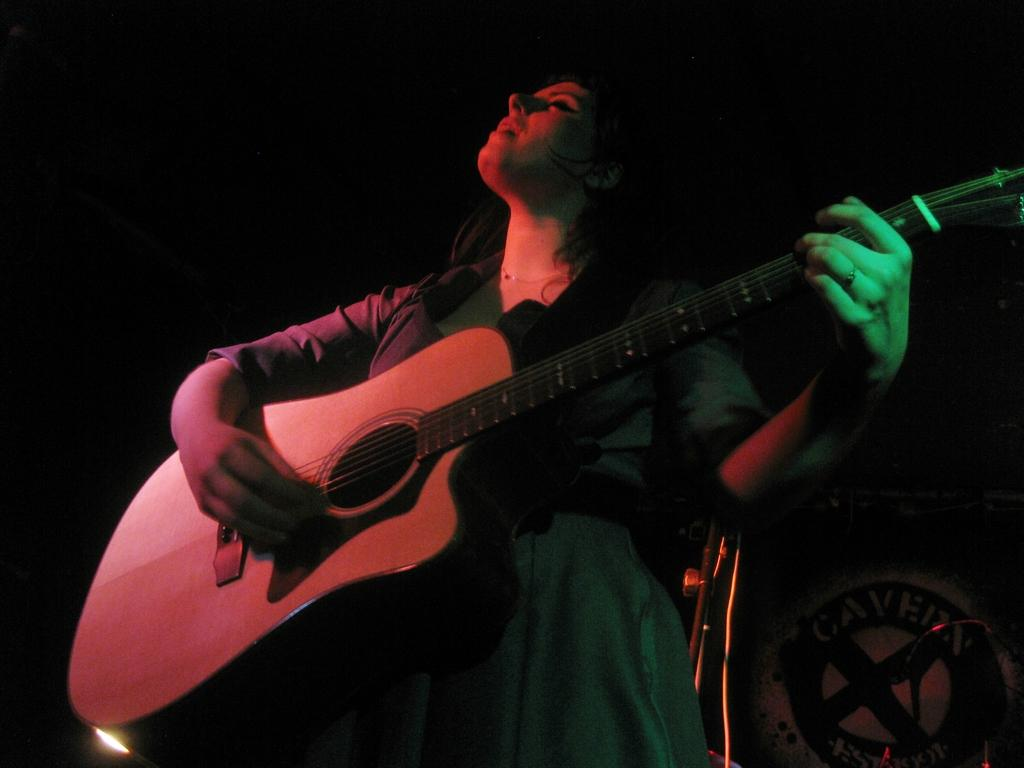Who is the main subject in the image? There is a woman in the image. What is the woman doing in the image? The woman is playing a guitar. What type of slope can be seen in the background of the image? There is no slope present in the image; it only features a woman playing a guitar. 